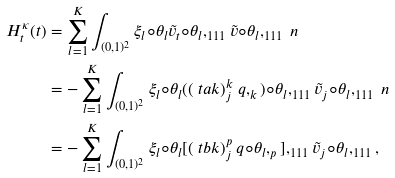<formula> <loc_0><loc_0><loc_500><loc_500>H ^ { \kappa } _ { t } ( t ) & = \sum _ { l = 1 } ^ { K } \int _ { ( 0 , 1 ) ^ { 2 } } \xi _ { l } \circ \theta _ { l } \tilde { v } _ { t } \circ \theta _ { l } , _ { 1 1 1 } \tilde { v } \circ \theta _ { l } , _ { 1 1 1 } \ n \\ & = - \sum _ { l = 1 } ^ { K } \int _ { ( 0 , 1 ) ^ { 2 } } \xi _ { l } \circ \theta _ { l } ( ( \ t a k ) _ { j } ^ { k } \ q , _ { k } ) \circ \theta _ { l } , _ { 1 1 1 } { \tilde { v } } _ { j } \circ \theta _ { l } , _ { 1 1 1 } \ n \\ & = - \sum _ { l = 1 } ^ { K } \int _ { ( 0 , 1 ) ^ { 2 } } \xi _ { l } \circ \theta _ { l } [ ( \ t b k ) _ { j } ^ { p } \ q \circ \theta _ { l } , _ { p } ] , _ { 1 1 1 } { \tilde { v } } _ { j } \circ \theta _ { l } , _ { 1 1 1 } ,</formula> 